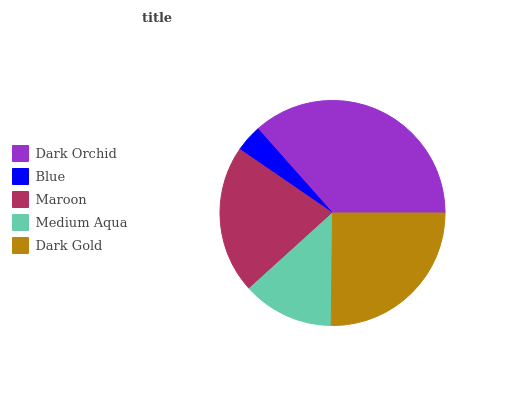Is Blue the minimum?
Answer yes or no. Yes. Is Dark Orchid the maximum?
Answer yes or no. Yes. Is Maroon the minimum?
Answer yes or no. No. Is Maroon the maximum?
Answer yes or no. No. Is Maroon greater than Blue?
Answer yes or no. Yes. Is Blue less than Maroon?
Answer yes or no. Yes. Is Blue greater than Maroon?
Answer yes or no. No. Is Maroon less than Blue?
Answer yes or no. No. Is Maroon the high median?
Answer yes or no. Yes. Is Maroon the low median?
Answer yes or no. Yes. Is Dark Gold the high median?
Answer yes or no. No. Is Medium Aqua the low median?
Answer yes or no. No. 